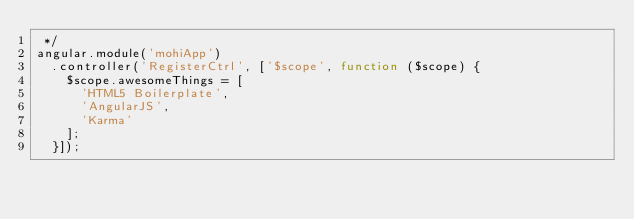Convert code to text. <code><loc_0><loc_0><loc_500><loc_500><_JavaScript_> */
angular.module('mohiApp')
  .controller('RegisterCtrl', ['$scope', function ($scope) {
    $scope.awesomeThings = [
      'HTML5 Boilerplate',
      'AngularJS',
      'Karma'
    ];
  }]);
</code> 